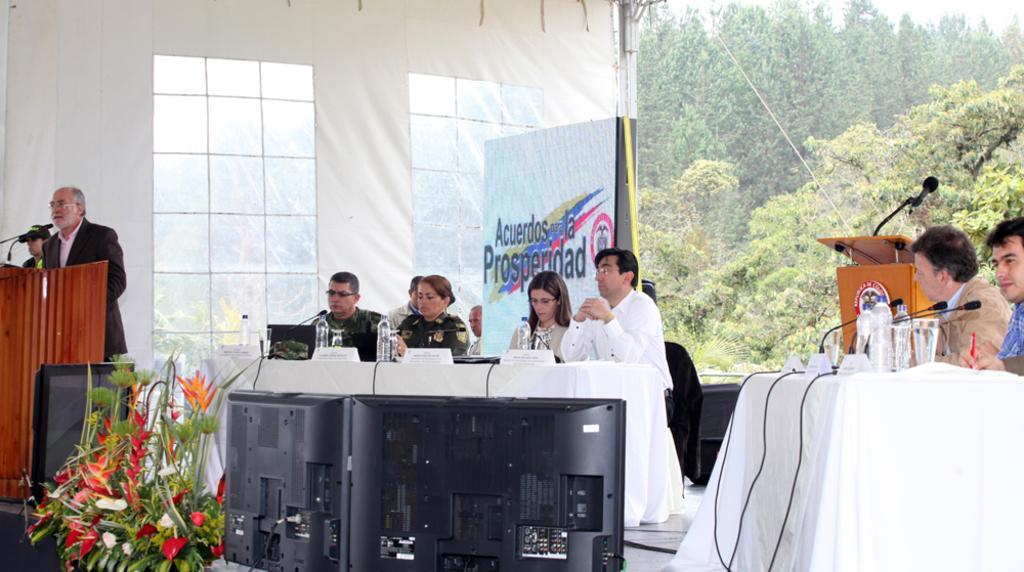How would you summarize this image in a sentence or two? In this picture I can see group of people sitting on the chairs, there are bottles, nameplates, glasses, mike's, laptops and some other objects on the tables, there is a person standing near the podium, there is another podium with the mike, there are flowers, speaker, tent, and some other items, and in the background there are trees and sky. 